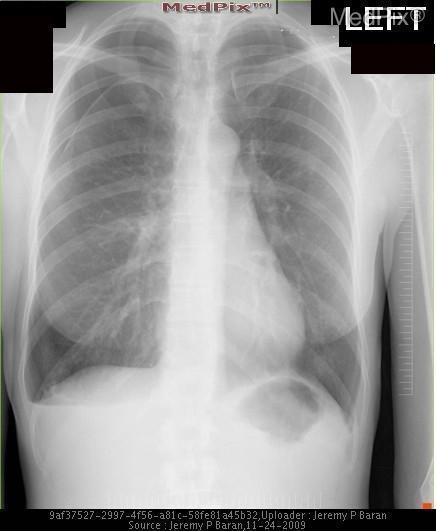Is a pneumothorax present?
Concise answer only. Yes. Is the heart displaced?
Be succinct. No. Is the heart in the wrong position?
Quick response, please. No. What indicates a pleural effusion?
Short answer required. Costophrenic angle blunting. What is a pleural effusion
Quick response, please. Fluid in the pleural space. Which way is the trachea deviating in this image?
Quick response, please. Left. Is the trachea deviated to the right or left?
Write a very short answer. Left. 